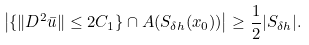Convert formula to latex. <formula><loc_0><loc_0><loc_500><loc_500>\left | \{ \| D ^ { 2 } \bar { u } \| \leq 2 C _ { 1 } \} \cap A ( S _ { \delta h } ( x _ { 0 } ) ) \right | \geq \frac { 1 } { 2 } | S _ { \delta h } | .</formula> 